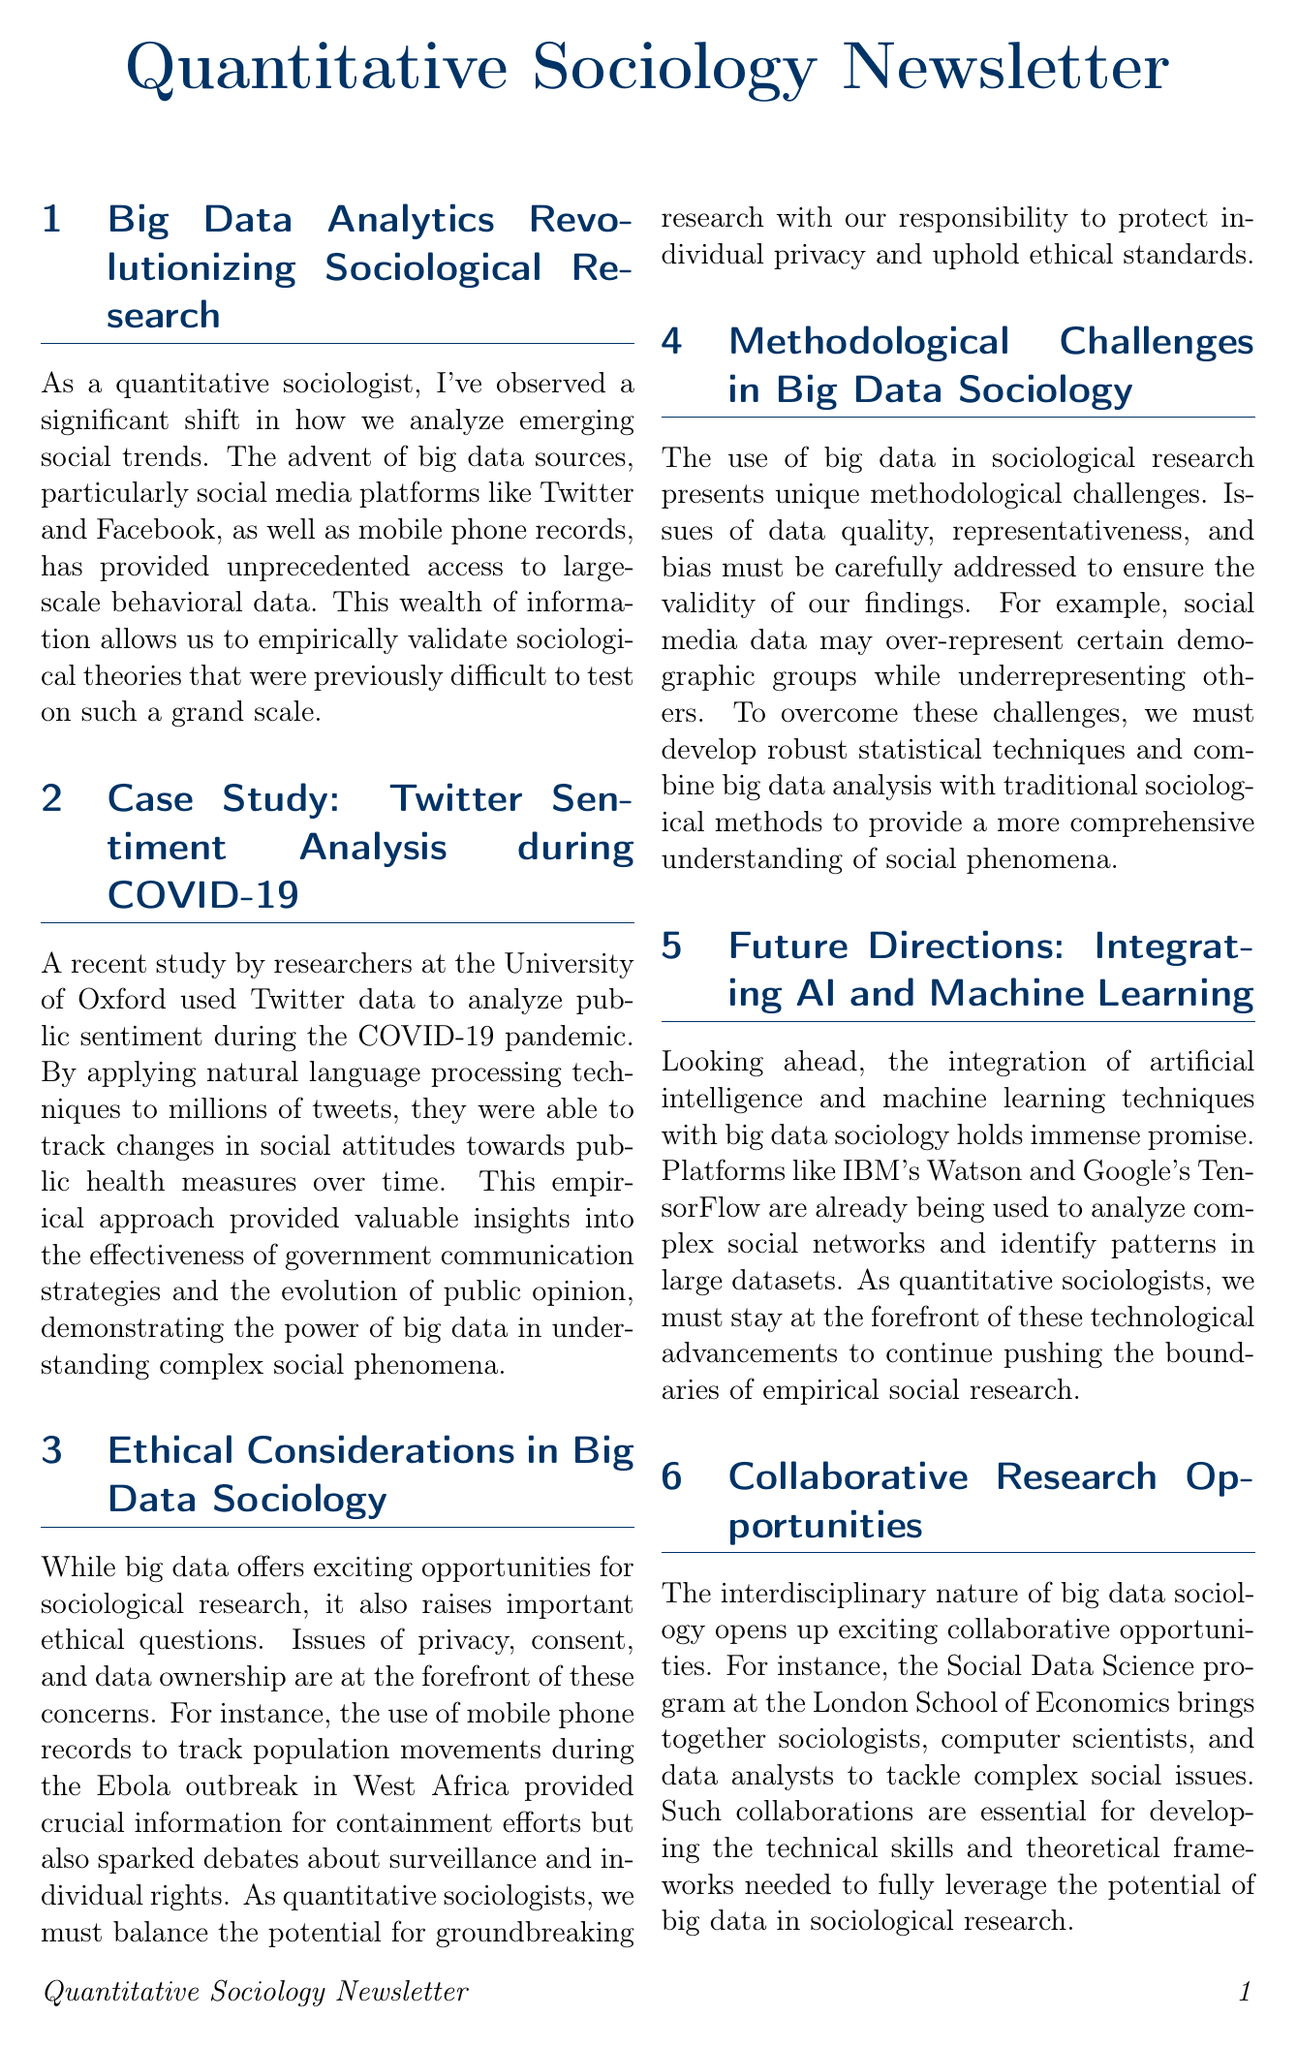What are the big data sources mentioned? The document lists social media platforms like Twitter and Facebook, as well as mobile phone records as big data sources.
Answer: Twitter, Facebook, mobile phone records Which university conducted the Twitter sentiment analysis study? The document states that the research was conducted by researchers at the University of Oxford.
Answer: University of Oxford What ethical issues are raised in the document? The document specifies privacy, consent, and data ownership as key ethical considerations.
Answer: Privacy, consent, data ownership What technological advancements are mentioned for future research? The document mentions the integration of artificial intelligence and machine learning techniques as future advancements in big data sociology.
Answer: Artificial intelligence, machine learning What is an example of a case study discussed in the newsletter? The newsletter provides an example of a case study analyzing public sentiment during the COVID-19 pandemic using Twitter data.
Answer: Twitter sentiment analysis during COVID-19 What type of research opportunities are highlighted in the document? Interdisciplinary collaborative research opportunities are emphasized, particularly the Social Data Science program at the London School of Economics.
Answer: Collaborative research opportunities What methodological challenges are associated with big data sociology? The document identifies issues of data quality, representativeness, and bias as methodological challenges.
Answer: Data quality, representativeness, bias What organization is mentioned for collaborative efforts in data science? The document mentions the Social Data Science program at the London School of Economics for collaborative research efforts.
Answer: London School of Economics 